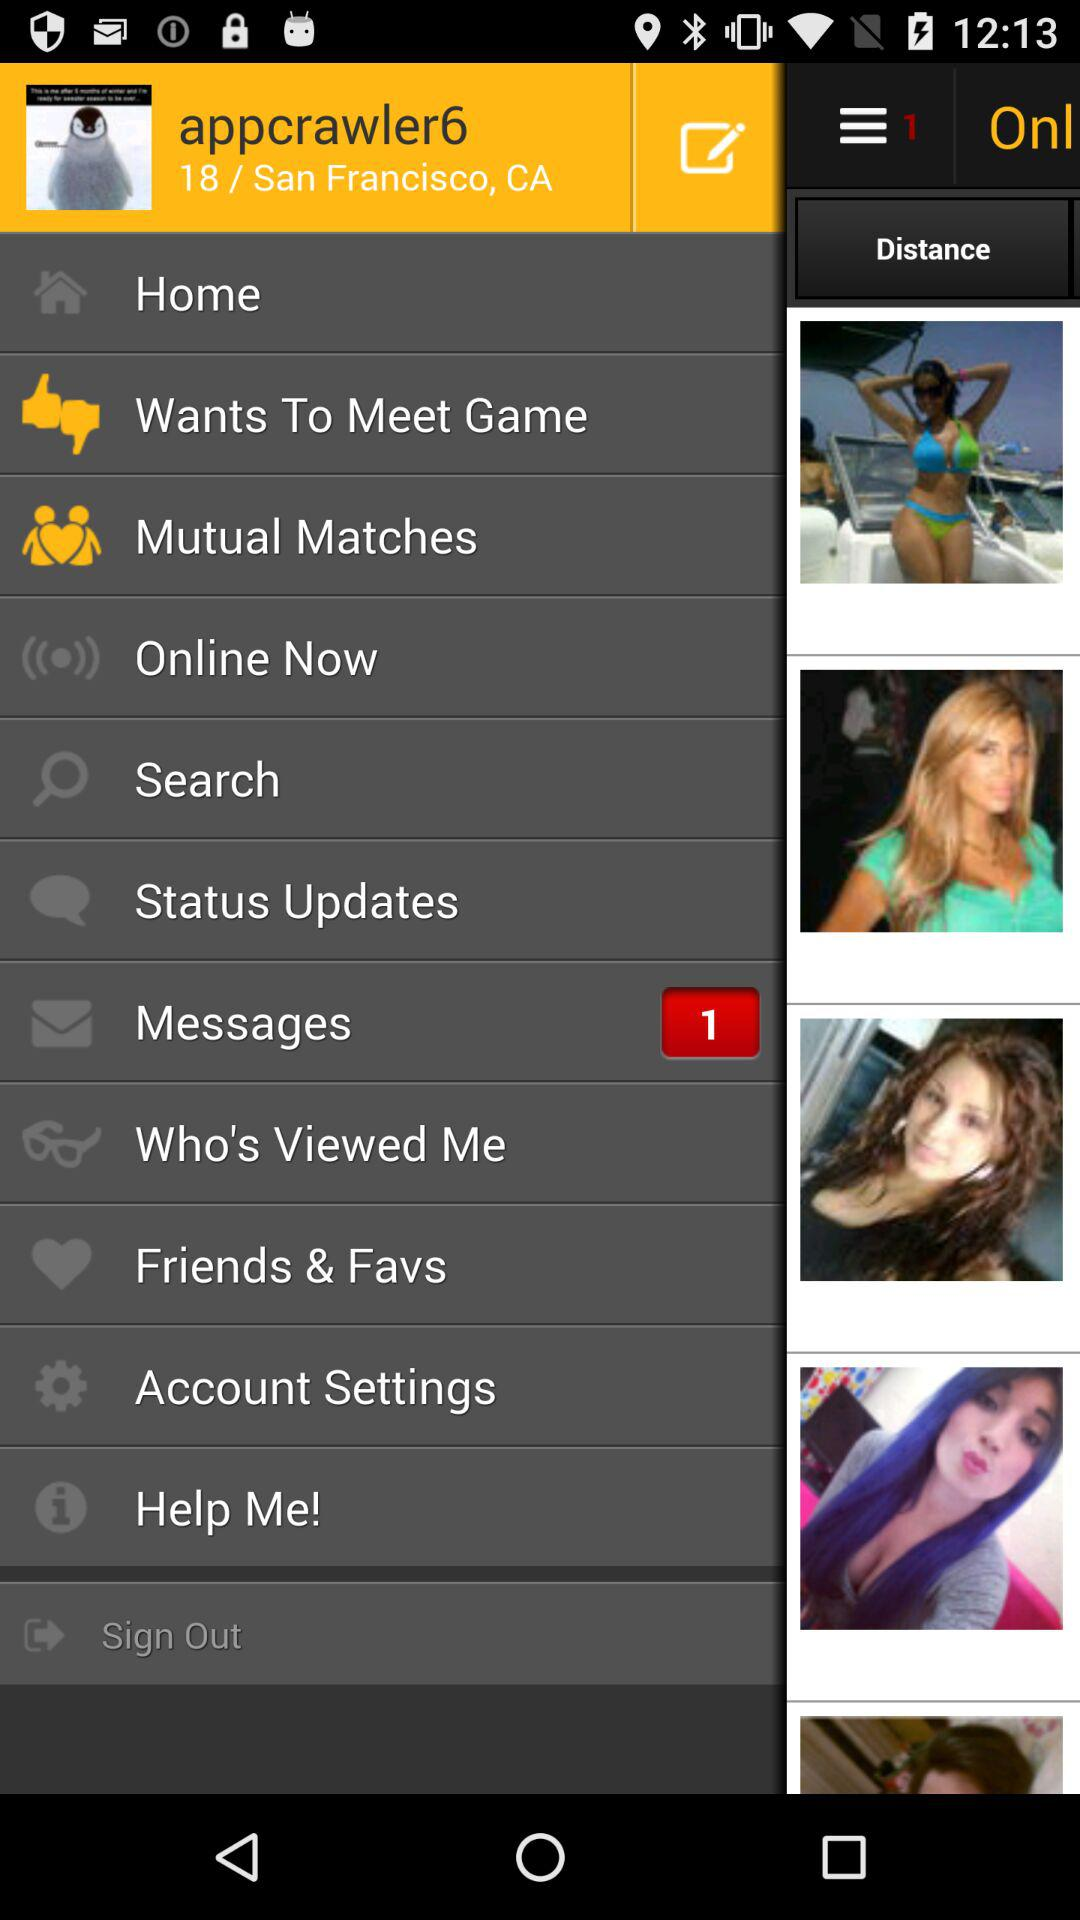What is the address? The address is San Francisco, CA. 